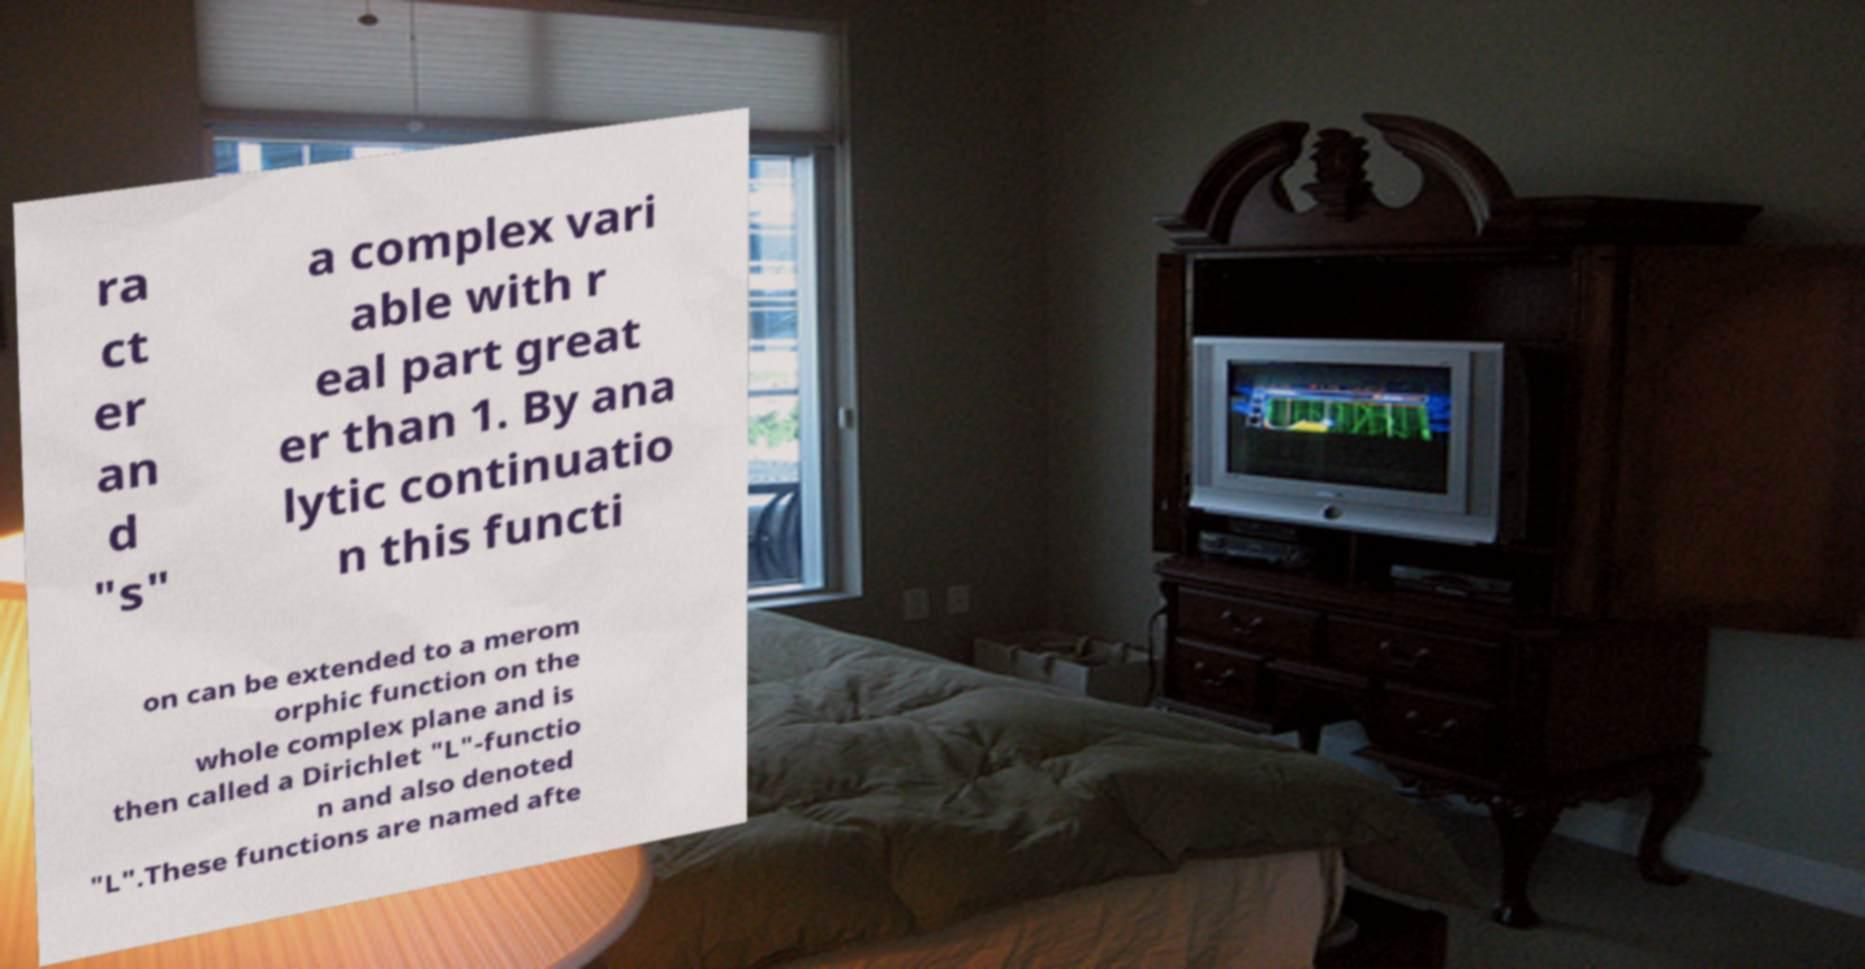There's text embedded in this image that I need extracted. Can you transcribe it verbatim? ra ct er an d "s" a complex vari able with r eal part great er than 1. By ana lytic continuatio n this functi on can be extended to a merom orphic function on the whole complex plane and is then called a Dirichlet "L"-functio n and also denoted "L".These functions are named afte 